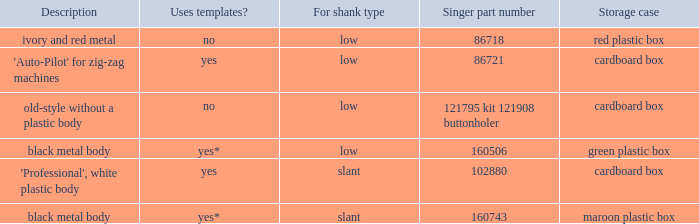What's the singer part number of the buttonholer whose storage case is a green plastic box? 160506.0. 